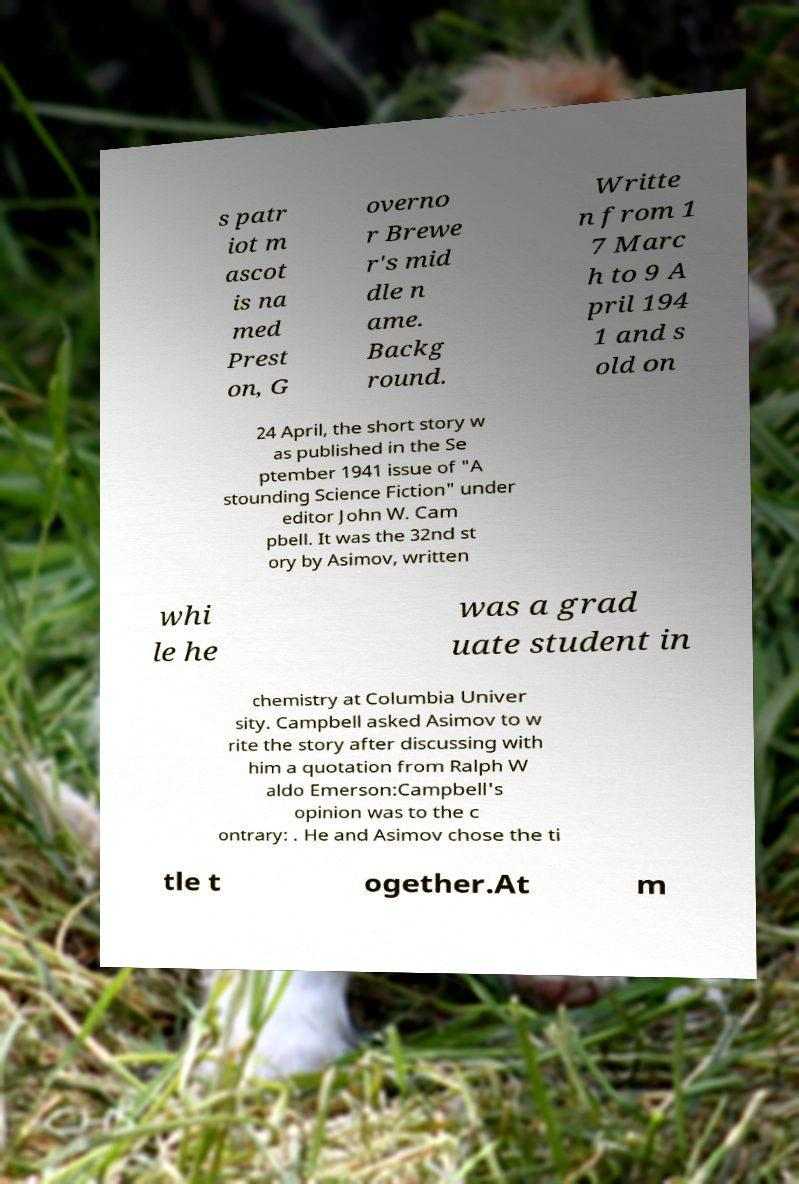There's text embedded in this image that I need extracted. Can you transcribe it verbatim? s patr iot m ascot is na med Prest on, G overno r Brewe r's mid dle n ame. Backg round. Writte n from 1 7 Marc h to 9 A pril 194 1 and s old on 24 April, the short story w as published in the Se ptember 1941 issue of "A stounding Science Fiction" under editor John W. Cam pbell. It was the 32nd st ory by Asimov, written whi le he was a grad uate student in chemistry at Columbia Univer sity. Campbell asked Asimov to w rite the story after discussing with him a quotation from Ralph W aldo Emerson:Campbell's opinion was to the c ontrary: . He and Asimov chose the ti tle t ogether.At m 